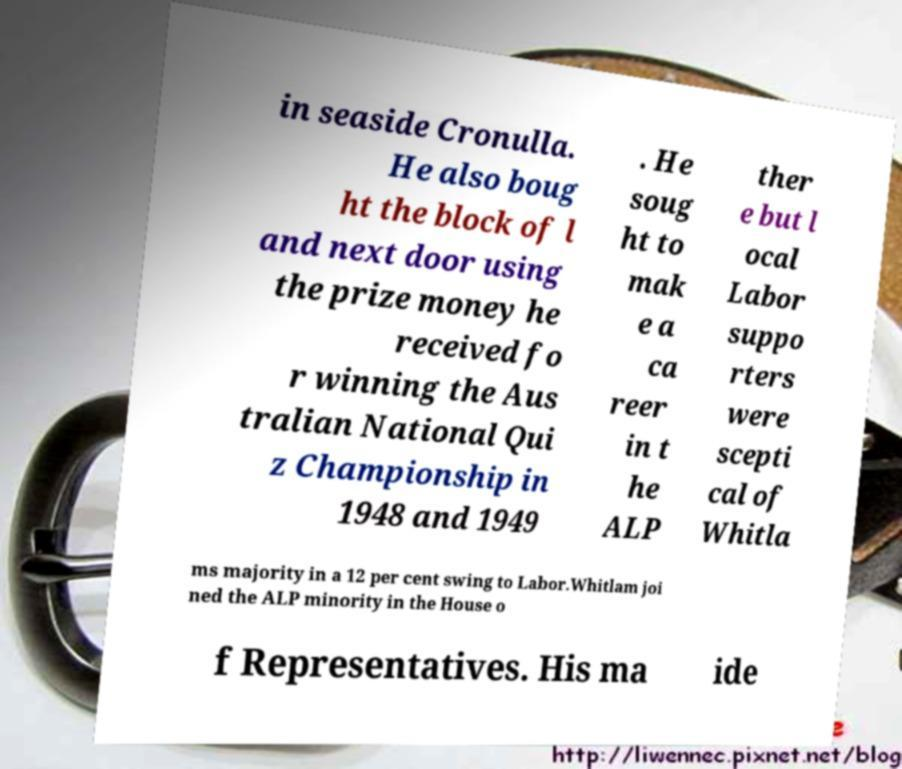For documentation purposes, I need the text within this image transcribed. Could you provide that? in seaside Cronulla. He also boug ht the block of l and next door using the prize money he received fo r winning the Aus tralian National Qui z Championship in 1948 and 1949 . He soug ht to mak e a ca reer in t he ALP ther e but l ocal Labor suppo rters were scepti cal of Whitla ms majority in a 12 per cent swing to Labor.Whitlam joi ned the ALP minority in the House o f Representatives. His ma ide 